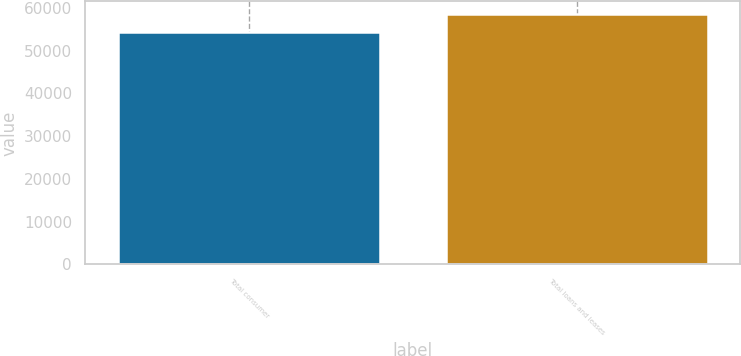Convert chart. <chart><loc_0><loc_0><loc_500><loc_500><bar_chart><fcel>Total consumer<fcel>Total loans and leases<nl><fcel>54275<fcel>58592<nl></chart> 